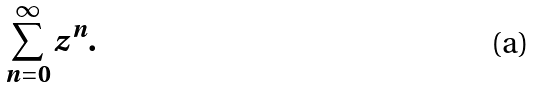<formula> <loc_0><loc_0><loc_500><loc_500>\sum _ { n = 0 } ^ { \infty } z ^ { n } .</formula> 